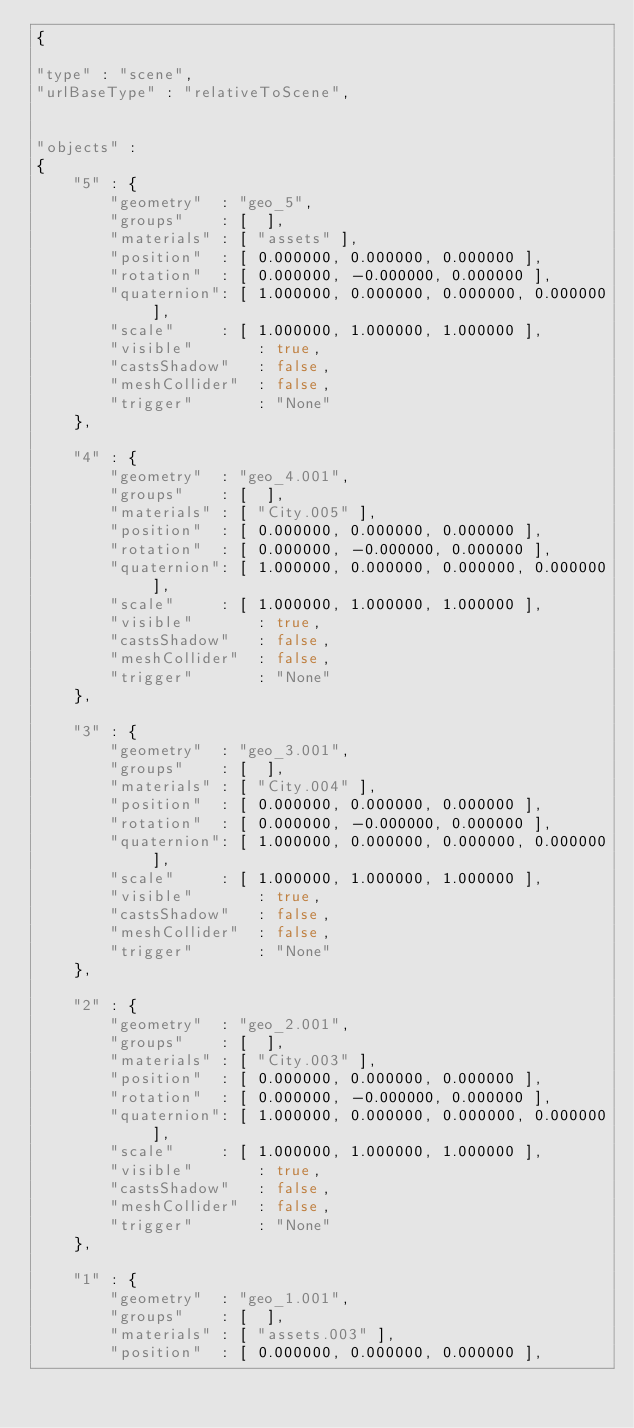Convert code to text. <code><loc_0><loc_0><loc_500><loc_500><_JavaScript_>{

"type" : "scene",
"urlBaseType" : "relativeToScene",


"objects" :
{
    "5" : {
        "geometry"  : "geo_5",
        "groups"    : [  ],
        "materials" : [ "assets" ],
        "position"  : [ 0.000000, 0.000000, 0.000000 ],
        "rotation"  : [ 0.000000, -0.000000, 0.000000 ],
        "quaternion": [ 1.000000, 0.000000, 0.000000, 0.000000 ],
        "scale"     : [ 1.000000, 1.000000, 1.000000 ],
        "visible"       : true,
        "castsShadow"   : false,
        "meshCollider"  : false,
        "trigger"       : "None"
    },

    "4" : {
        "geometry"  : "geo_4.001",
        "groups"    : [  ],
        "materials" : [ "City.005" ],
        "position"  : [ 0.000000, 0.000000, 0.000000 ],
        "rotation"  : [ 0.000000, -0.000000, 0.000000 ],
        "quaternion": [ 1.000000, 0.000000, 0.000000, 0.000000 ],
        "scale"     : [ 1.000000, 1.000000, 1.000000 ],
        "visible"       : true,
        "castsShadow"   : false,
        "meshCollider"  : false,
        "trigger"       : "None"
    },

    "3" : {
        "geometry"  : "geo_3.001",
        "groups"    : [  ],
        "materials" : [ "City.004" ],
        "position"  : [ 0.000000, 0.000000, 0.000000 ],
        "rotation"  : [ 0.000000, -0.000000, 0.000000 ],
        "quaternion": [ 1.000000, 0.000000, 0.000000, 0.000000 ],
        "scale"     : [ 1.000000, 1.000000, 1.000000 ],
        "visible"       : true,
        "castsShadow"   : false,
        "meshCollider"  : false,
        "trigger"       : "None"
    },

    "2" : {
        "geometry"  : "geo_2.001",
        "groups"    : [  ],
        "materials" : [ "City.003" ],
        "position"  : [ 0.000000, 0.000000, 0.000000 ],
        "rotation"  : [ 0.000000, -0.000000, 0.000000 ],
        "quaternion": [ 1.000000, 0.000000, 0.000000, 0.000000 ],
        "scale"     : [ 1.000000, 1.000000, 1.000000 ],
        "visible"       : true,
        "castsShadow"   : false,
        "meshCollider"  : false,
        "trigger"       : "None"
    },

    "1" : {
        "geometry"  : "geo_1.001",
        "groups"    : [  ],
        "materials" : [ "assets.003" ],
        "position"  : [ 0.000000, 0.000000, 0.000000 ],</code> 